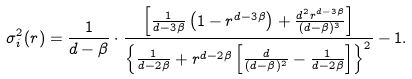<formula> <loc_0><loc_0><loc_500><loc_500>\sigma ^ { 2 } _ { i } ( r ) = \frac { 1 } { d - \beta } \cdot \frac { \left [ \frac { 1 } { d - 3 \beta } \left ( 1 - r ^ { d - 3 \beta } \right ) + \frac { d ^ { 2 } r ^ { d - 3 \beta } } { ( d - \beta ) ^ { 3 } } \right ] } { \left \{ \frac { 1 } { d - 2 \beta } + r ^ { d - 2 \beta } \left [ \frac { d } { ( d - \beta ) ^ { 2 } } - \frac { 1 } { d - 2 \beta } \right ] \right \} ^ { 2 } } - 1 .</formula> 